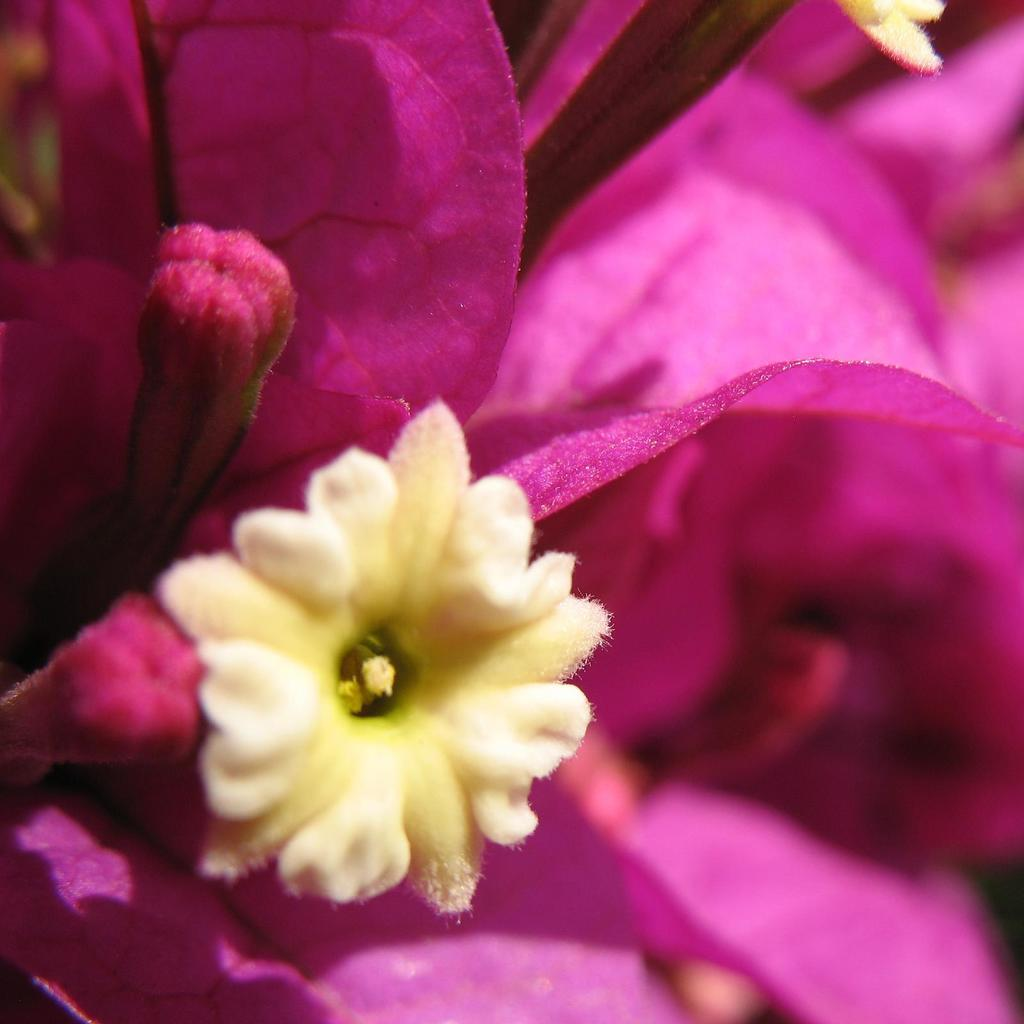What is the main subject of the picture? The main subject of the picture is a flower. Can you describe the colors of the flower? The flower has pink and cream colors. What stage of growth is the flower in? There is a bud on the flower, indicating that it is in the early stages of blooming. How many ladybugs can be seen on the board in the image? There is no board or ladybugs present in the image; it features a flower with a bud. What type of card is visible next to the flower in the image? There is no card present in the image; it only features a flower with a bud. 